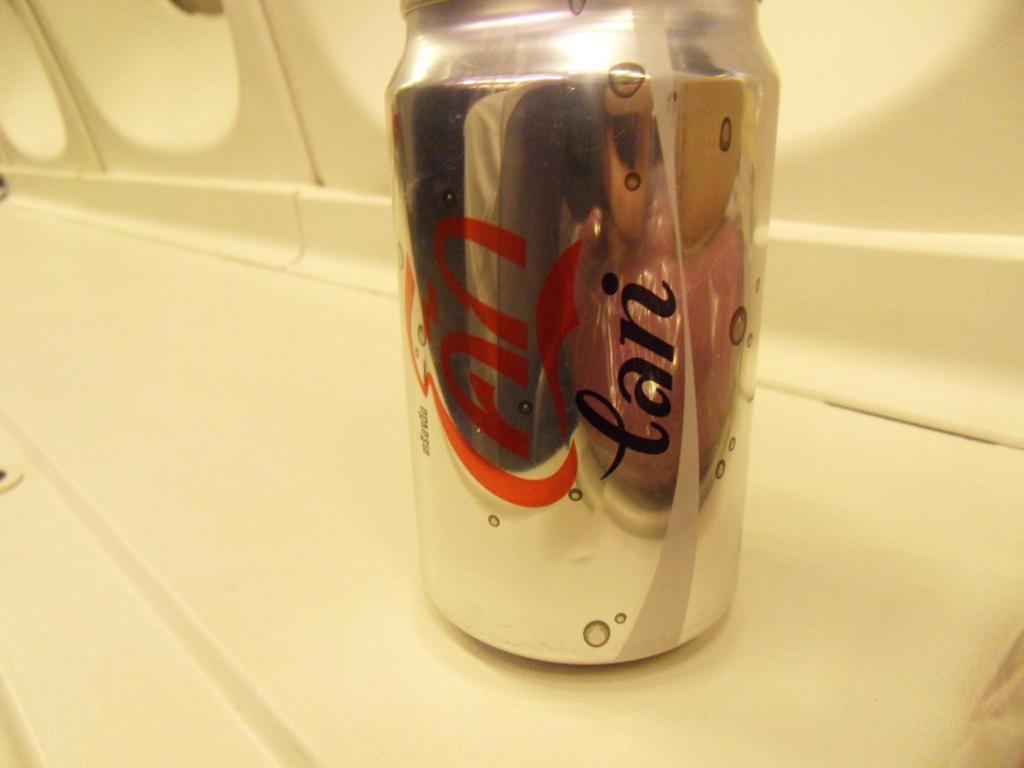What object is the main focus of the image? There is a can in the image. What can be seen in the background of the image? There is a countertop in the background of the image. What type of punishment is being administered to the can in the image? There is no punishment being administered to the can in the image; it is simply a can sitting on a countertop. 